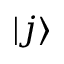<formula> <loc_0><loc_0><loc_500><loc_500>| j \rangle</formula> 